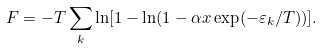Convert formula to latex. <formula><loc_0><loc_0><loc_500><loc_500>F = - T \sum _ { k } \ln [ 1 - \ln ( 1 - \alpha x \exp ( - \varepsilon _ { k } / T ) ) ] .</formula> 